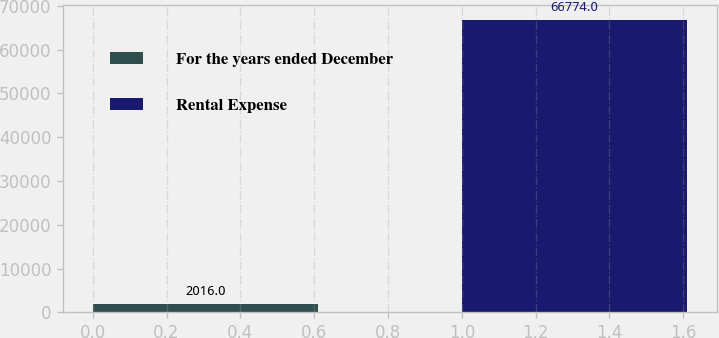Convert chart. <chart><loc_0><loc_0><loc_500><loc_500><bar_chart><fcel>For the years ended December<fcel>Rental Expense<nl><fcel>2016<fcel>66774<nl></chart> 